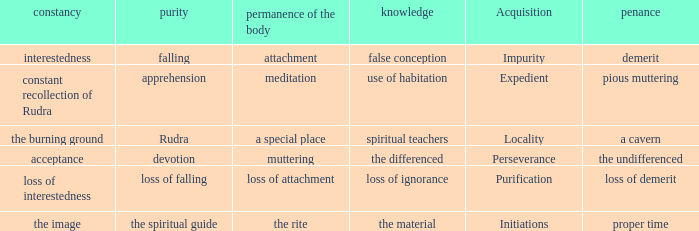 what's the permanence of the body where purity is apprehension Meditation. 